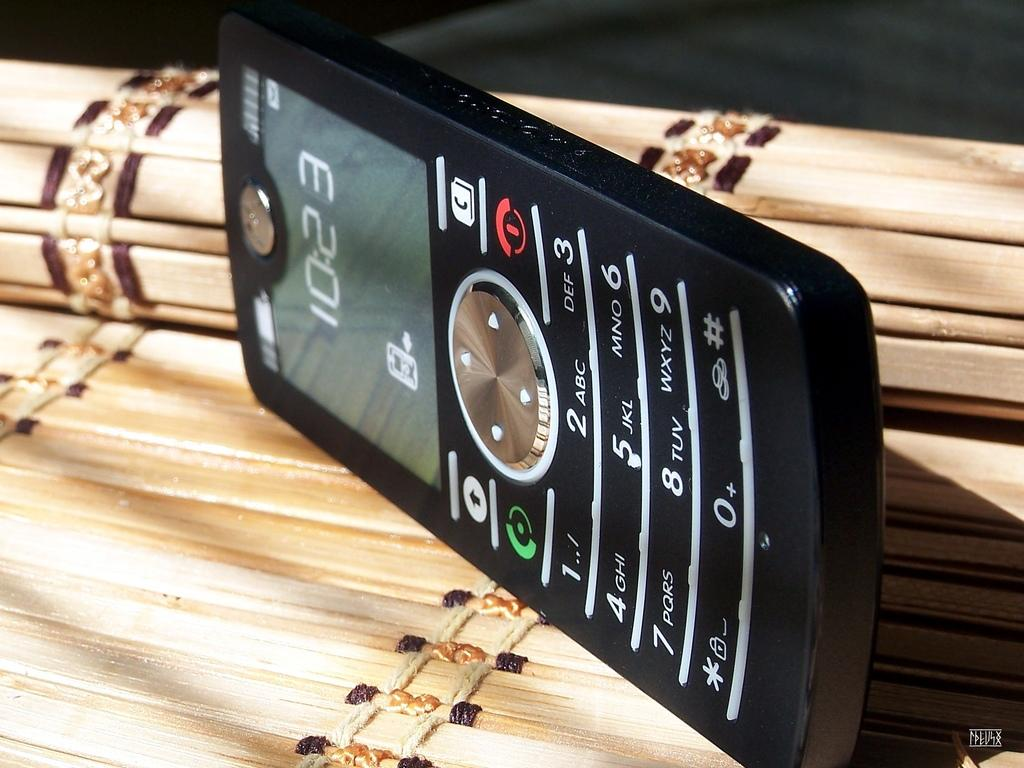Provide a one-sentence caption for the provided image. The time shown on the mobile phone is 10:23. 